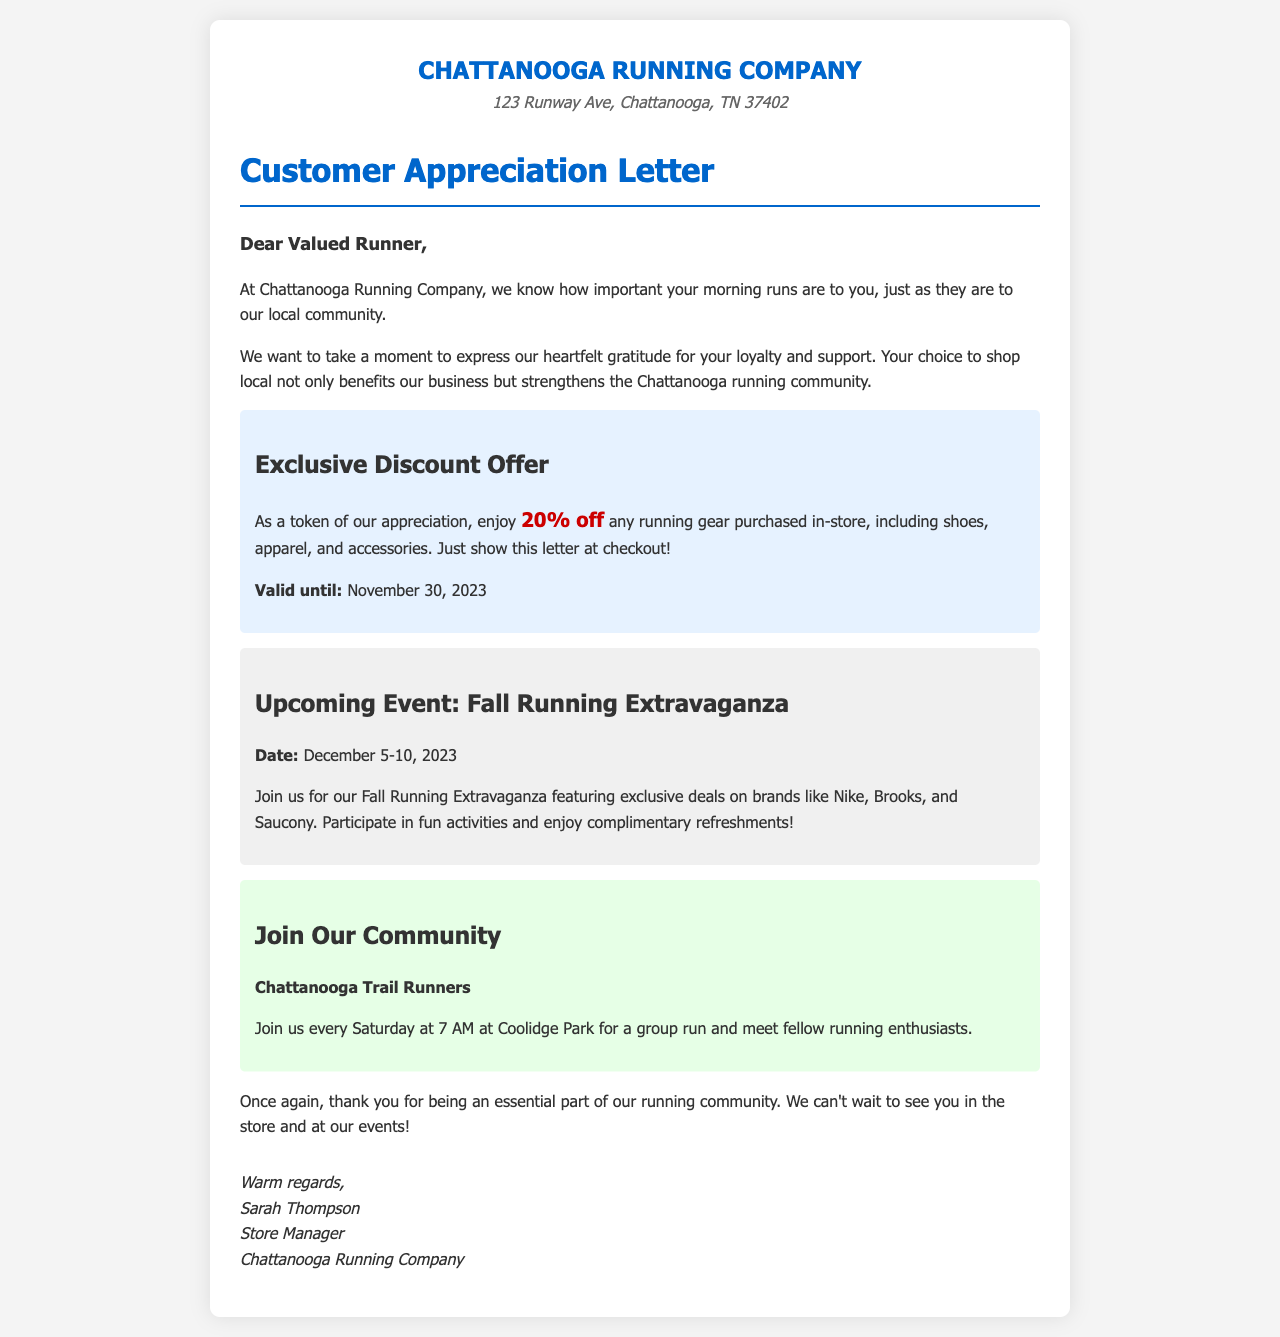What is the name of the store? The name of the store is prominently mentioned at the top of the document.
Answer: Chattanooga Running Company What is the address of the store? The address is listed below the store name in the header section.
Answer: 123 Runway Ave, Chattanooga, TN 37402 What is the exclusive discount offered? The specific discount is highlighted in the document for customers.
Answer: 20% off When is the discount valid until? The validity period of the discount is mentioned clearly in the letter.
Answer: November 30, 2023 What is the date of the upcoming event? The date of the event is provided in the event section of the letter.
Answer: December 5-10, 2023 What is the name of the community group mentioned? The community group is specifically named in the community section of the letter.
Answer: Chattanooga Trail Runners What time do the community group runs start? The document states the meeting time for the community group.
Answer: 7 AM Who is the signatory of the letter? The person who signs off the letter is stated at the bottom.
Answer: Sarah Thompson What type of activities will be at the Fall Running Extravaganza? The letter mentions various activities that will take place during the event.
Answer: Fun activities 